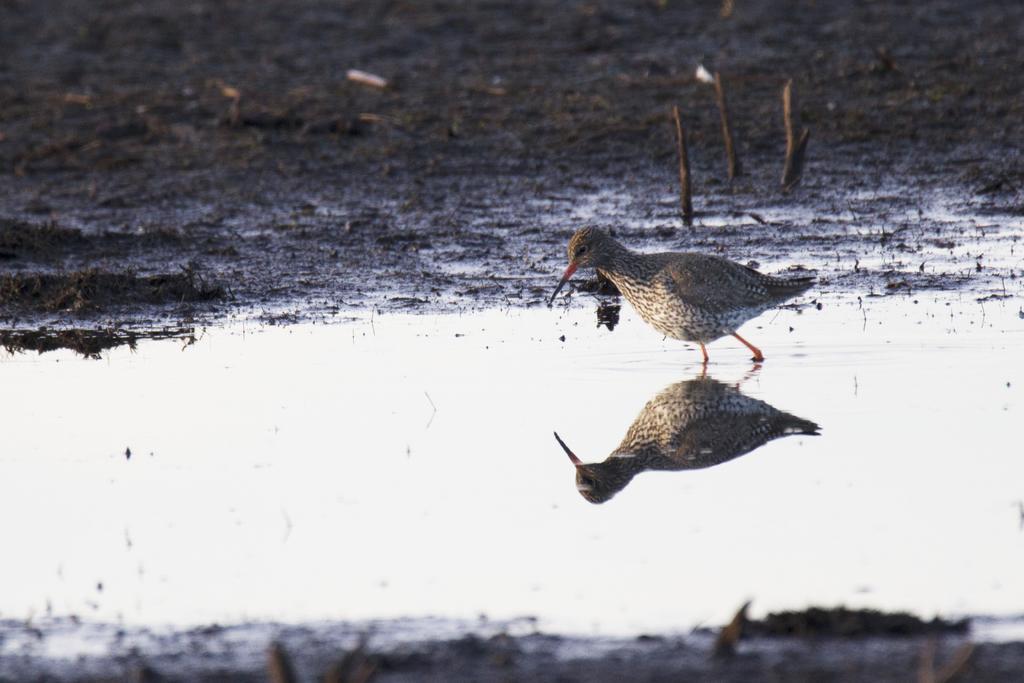Please provide a concise description of this image. In this picture I can observe bird in the middle of the picture. The bird is walking in the water. In the background I can observe an open land. 